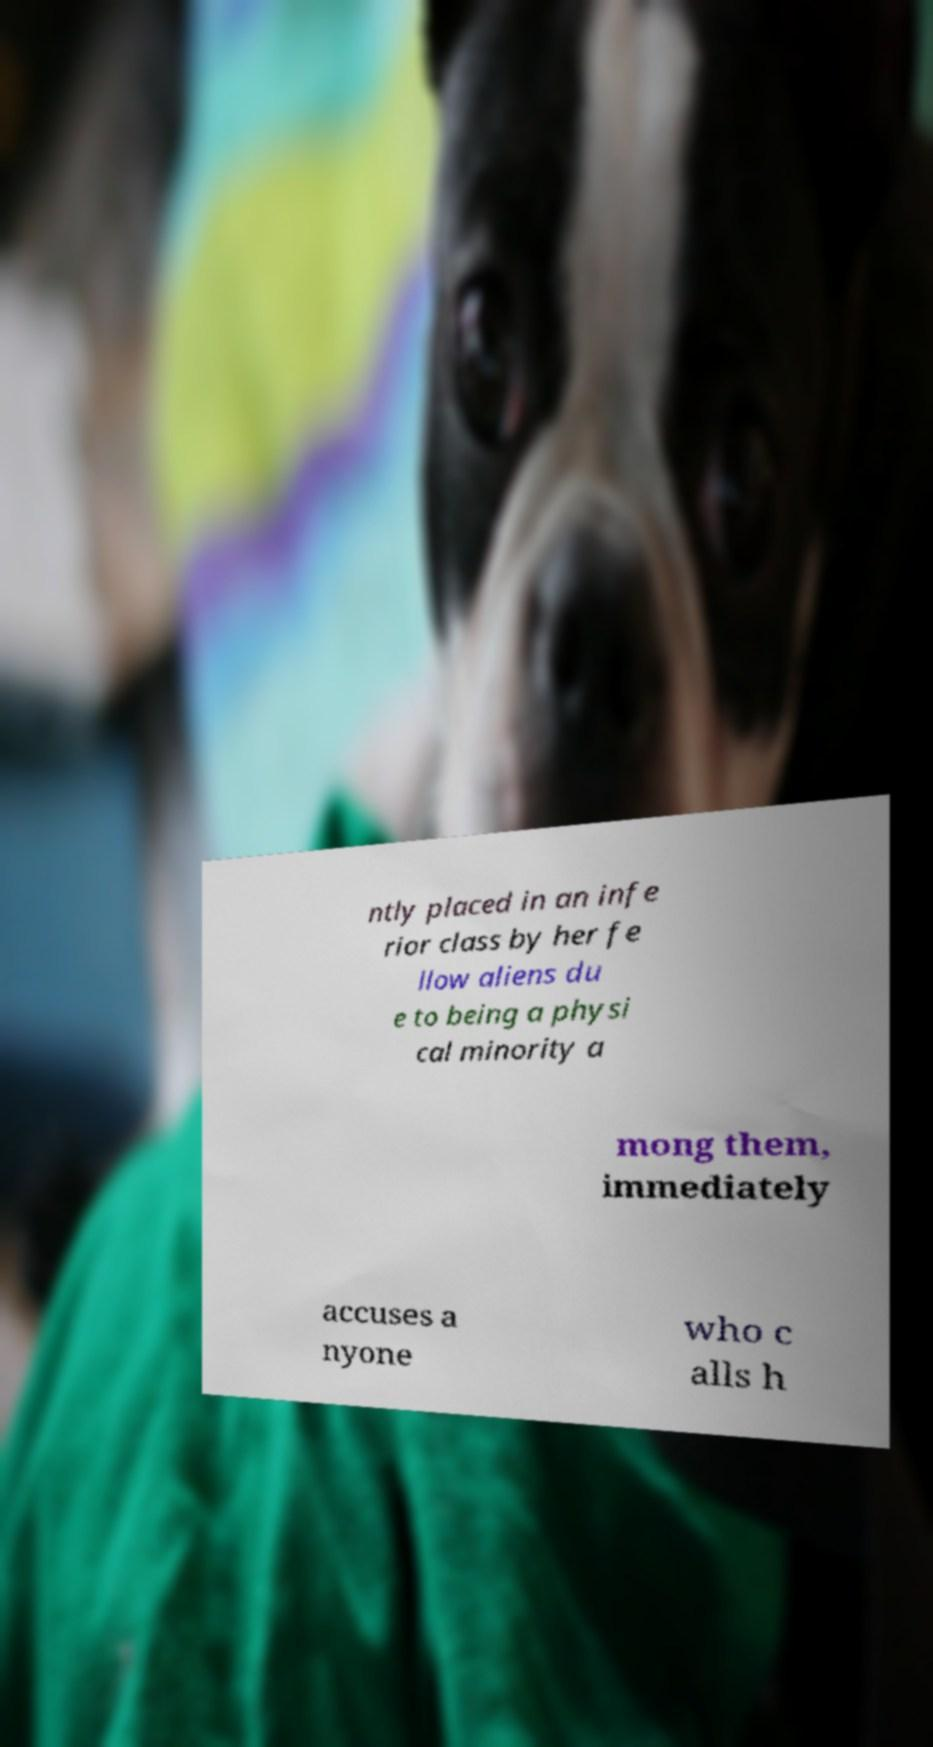Could you assist in decoding the text presented in this image and type it out clearly? ntly placed in an infe rior class by her fe llow aliens du e to being a physi cal minority a mong them, immediately accuses a nyone who c alls h 